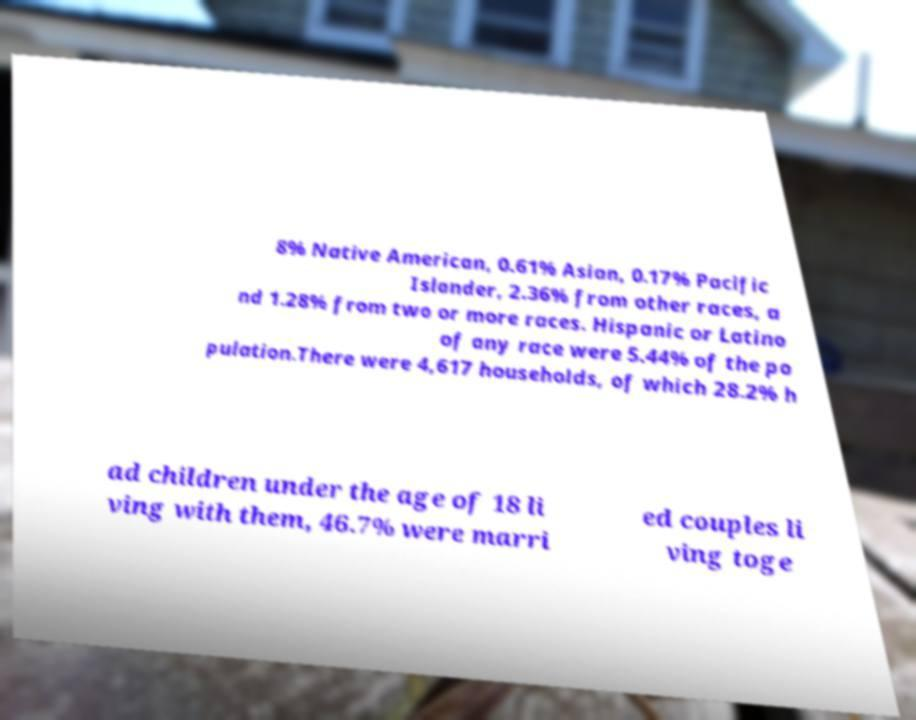For documentation purposes, I need the text within this image transcribed. Could you provide that? 8% Native American, 0.61% Asian, 0.17% Pacific Islander, 2.36% from other races, a nd 1.28% from two or more races. Hispanic or Latino of any race were 5.44% of the po pulation.There were 4,617 households, of which 28.2% h ad children under the age of 18 li ving with them, 46.7% were marri ed couples li ving toge 